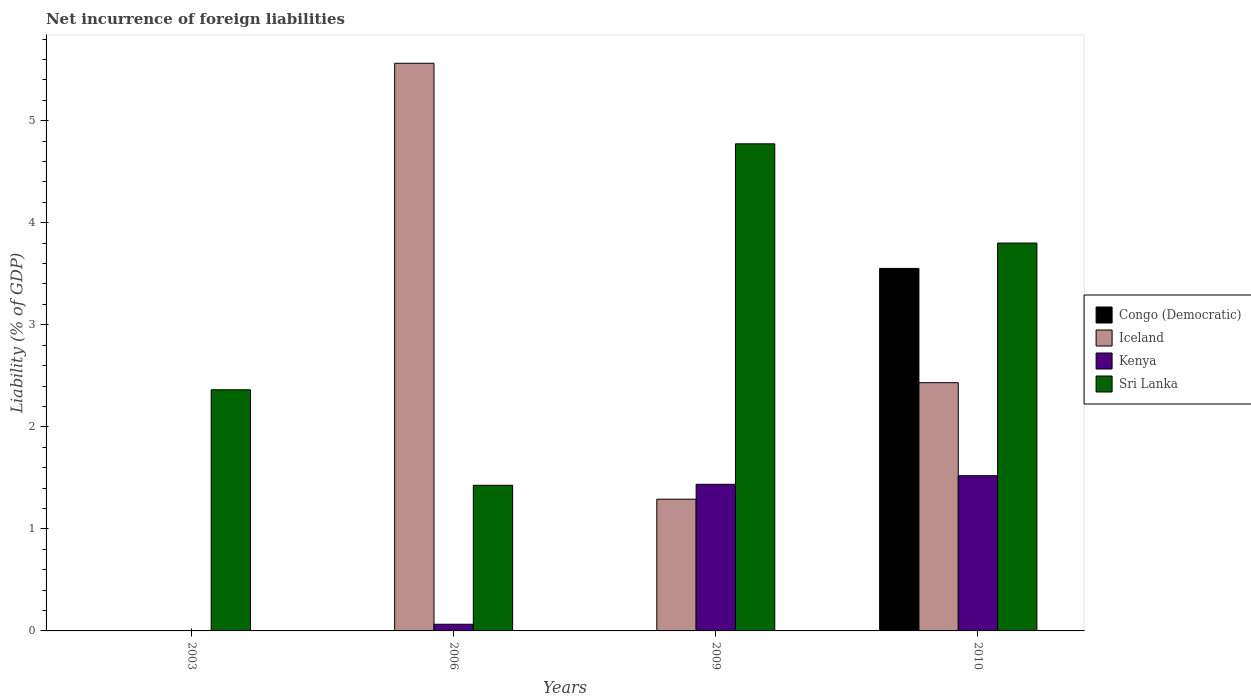How many different coloured bars are there?
Ensure brevity in your answer.  4. Are the number of bars per tick equal to the number of legend labels?
Your answer should be compact. No. Are the number of bars on each tick of the X-axis equal?
Provide a short and direct response. No. How many bars are there on the 3rd tick from the left?
Give a very brief answer. 3. How many bars are there on the 2nd tick from the right?
Give a very brief answer. 3. What is the label of the 2nd group of bars from the left?
Offer a very short reply. 2006. In how many cases, is the number of bars for a given year not equal to the number of legend labels?
Ensure brevity in your answer.  3. What is the net incurrence of foreign liabilities in Kenya in 2010?
Give a very brief answer. 1.52. Across all years, what is the maximum net incurrence of foreign liabilities in Congo (Democratic)?
Your answer should be very brief. 3.55. Across all years, what is the minimum net incurrence of foreign liabilities in Sri Lanka?
Give a very brief answer. 1.43. In which year was the net incurrence of foreign liabilities in Kenya maximum?
Ensure brevity in your answer.  2010. What is the total net incurrence of foreign liabilities in Kenya in the graph?
Provide a succinct answer. 3.02. What is the difference between the net incurrence of foreign liabilities in Kenya in 2009 and that in 2010?
Give a very brief answer. -0.08. What is the difference between the net incurrence of foreign liabilities in Iceland in 2003 and the net incurrence of foreign liabilities in Congo (Democratic) in 2009?
Offer a terse response. 0. What is the average net incurrence of foreign liabilities in Sri Lanka per year?
Offer a very short reply. 3.09. In the year 2010, what is the difference between the net incurrence of foreign liabilities in Iceland and net incurrence of foreign liabilities in Sri Lanka?
Provide a short and direct response. -1.37. In how many years, is the net incurrence of foreign liabilities in Sri Lanka greater than 1 %?
Your response must be concise. 4. What is the ratio of the net incurrence of foreign liabilities in Sri Lanka in 2006 to that in 2009?
Provide a succinct answer. 0.3. What is the difference between the highest and the second highest net incurrence of foreign liabilities in Iceland?
Make the answer very short. 3.13. What is the difference between the highest and the lowest net incurrence of foreign liabilities in Iceland?
Offer a very short reply. 5.56. In how many years, is the net incurrence of foreign liabilities in Iceland greater than the average net incurrence of foreign liabilities in Iceland taken over all years?
Provide a short and direct response. 2. How many years are there in the graph?
Provide a short and direct response. 4. What is the difference between two consecutive major ticks on the Y-axis?
Offer a terse response. 1. Are the values on the major ticks of Y-axis written in scientific E-notation?
Offer a very short reply. No. Does the graph contain any zero values?
Offer a terse response. Yes. Does the graph contain grids?
Provide a short and direct response. No. Where does the legend appear in the graph?
Your answer should be very brief. Center right. How many legend labels are there?
Ensure brevity in your answer.  4. How are the legend labels stacked?
Give a very brief answer. Vertical. What is the title of the graph?
Your response must be concise. Net incurrence of foreign liabilities. What is the label or title of the X-axis?
Ensure brevity in your answer.  Years. What is the label or title of the Y-axis?
Your answer should be compact. Liability (% of GDP). What is the Liability (% of GDP) in Congo (Democratic) in 2003?
Give a very brief answer. 0. What is the Liability (% of GDP) of Iceland in 2003?
Give a very brief answer. 0. What is the Liability (% of GDP) of Kenya in 2003?
Keep it short and to the point. 0. What is the Liability (% of GDP) of Sri Lanka in 2003?
Give a very brief answer. 2.36. What is the Liability (% of GDP) of Congo (Democratic) in 2006?
Your answer should be very brief. 0. What is the Liability (% of GDP) in Iceland in 2006?
Make the answer very short. 5.56. What is the Liability (% of GDP) of Kenya in 2006?
Provide a succinct answer. 0.07. What is the Liability (% of GDP) in Sri Lanka in 2006?
Give a very brief answer. 1.43. What is the Liability (% of GDP) of Iceland in 2009?
Your answer should be very brief. 1.29. What is the Liability (% of GDP) of Kenya in 2009?
Your answer should be compact. 1.44. What is the Liability (% of GDP) of Sri Lanka in 2009?
Ensure brevity in your answer.  4.77. What is the Liability (% of GDP) of Congo (Democratic) in 2010?
Offer a very short reply. 3.55. What is the Liability (% of GDP) in Iceland in 2010?
Offer a terse response. 2.43. What is the Liability (% of GDP) of Kenya in 2010?
Keep it short and to the point. 1.52. What is the Liability (% of GDP) of Sri Lanka in 2010?
Your answer should be very brief. 3.8. Across all years, what is the maximum Liability (% of GDP) in Congo (Democratic)?
Your response must be concise. 3.55. Across all years, what is the maximum Liability (% of GDP) of Iceland?
Give a very brief answer. 5.56. Across all years, what is the maximum Liability (% of GDP) of Kenya?
Give a very brief answer. 1.52. Across all years, what is the maximum Liability (% of GDP) in Sri Lanka?
Your answer should be very brief. 4.77. Across all years, what is the minimum Liability (% of GDP) of Kenya?
Keep it short and to the point. 0. Across all years, what is the minimum Liability (% of GDP) in Sri Lanka?
Your answer should be very brief. 1.43. What is the total Liability (% of GDP) of Congo (Democratic) in the graph?
Keep it short and to the point. 3.55. What is the total Liability (% of GDP) of Iceland in the graph?
Offer a terse response. 9.29. What is the total Liability (% of GDP) of Kenya in the graph?
Give a very brief answer. 3.02. What is the total Liability (% of GDP) of Sri Lanka in the graph?
Your answer should be very brief. 12.36. What is the difference between the Liability (% of GDP) of Sri Lanka in 2003 and that in 2006?
Your answer should be compact. 0.94. What is the difference between the Liability (% of GDP) in Sri Lanka in 2003 and that in 2009?
Ensure brevity in your answer.  -2.41. What is the difference between the Liability (% of GDP) of Sri Lanka in 2003 and that in 2010?
Offer a very short reply. -1.44. What is the difference between the Liability (% of GDP) in Iceland in 2006 and that in 2009?
Provide a short and direct response. 4.27. What is the difference between the Liability (% of GDP) of Kenya in 2006 and that in 2009?
Provide a succinct answer. -1.37. What is the difference between the Liability (% of GDP) in Sri Lanka in 2006 and that in 2009?
Keep it short and to the point. -3.35. What is the difference between the Liability (% of GDP) in Iceland in 2006 and that in 2010?
Offer a terse response. 3.13. What is the difference between the Liability (% of GDP) of Kenya in 2006 and that in 2010?
Provide a short and direct response. -1.46. What is the difference between the Liability (% of GDP) of Sri Lanka in 2006 and that in 2010?
Offer a very short reply. -2.37. What is the difference between the Liability (% of GDP) of Iceland in 2009 and that in 2010?
Keep it short and to the point. -1.14. What is the difference between the Liability (% of GDP) of Kenya in 2009 and that in 2010?
Offer a terse response. -0.08. What is the difference between the Liability (% of GDP) of Sri Lanka in 2009 and that in 2010?
Make the answer very short. 0.97. What is the difference between the Liability (% of GDP) of Iceland in 2006 and the Liability (% of GDP) of Kenya in 2009?
Make the answer very short. 4.13. What is the difference between the Liability (% of GDP) in Iceland in 2006 and the Liability (% of GDP) in Sri Lanka in 2009?
Ensure brevity in your answer.  0.79. What is the difference between the Liability (% of GDP) of Kenya in 2006 and the Liability (% of GDP) of Sri Lanka in 2009?
Offer a terse response. -4.71. What is the difference between the Liability (% of GDP) in Iceland in 2006 and the Liability (% of GDP) in Kenya in 2010?
Make the answer very short. 4.04. What is the difference between the Liability (% of GDP) in Iceland in 2006 and the Liability (% of GDP) in Sri Lanka in 2010?
Your answer should be very brief. 1.76. What is the difference between the Liability (% of GDP) of Kenya in 2006 and the Liability (% of GDP) of Sri Lanka in 2010?
Ensure brevity in your answer.  -3.74. What is the difference between the Liability (% of GDP) of Iceland in 2009 and the Liability (% of GDP) of Kenya in 2010?
Provide a succinct answer. -0.23. What is the difference between the Liability (% of GDP) of Iceland in 2009 and the Liability (% of GDP) of Sri Lanka in 2010?
Make the answer very short. -2.51. What is the difference between the Liability (% of GDP) of Kenya in 2009 and the Liability (% of GDP) of Sri Lanka in 2010?
Make the answer very short. -2.36. What is the average Liability (% of GDP) in Congo (Democratic) per year?
Provide a succinct answer. 0.89. What is the average Liability (% of GDP) in Iceland per year?
Keep it short and to the point. 2.32. What is the average Liability (% of GDP) in Kenya per year?
Your answer should be very brief. 0.76. What is the average Liability (% of GDP) of Sri Lanka per year?
Provide a short and direct response. 3.09. In the year 2006, what is the difference between the Liability (% of GDP) in Iceland and Liability (% of GDP) in Kenya?
Offer a very short reply. 5.5. In the year 2006, what is the difference between the Liability (% of GDP) of Iceland and Liability (% of GDP) of Sri Lanka?
Make the answer very short. 4.14. In the year 2006, what is the difference between the Liability (% of GDP) of Kenya and Liability (% of GDP) of Sri Lanka?
Keep it short and to the point. -1.36. In the year 2009, what is the difference between the Liability (% of GDP) in Iceland and Liability (% of GDP) in Kenya?
Offer a very short reply. -0.15. In the year 2009, what is the difference between the Liability (% of GDP) in Iceland and Liability (% of GDP) in Sri Lanka?
Offer a terse response. -3.48. In the year 2009, what is the difference between the Liability (% of GDP) in Kenya and Liability (% of GDP) in Sri Lanka?
Keep it short and to the point. -3.34. In the year 2010, what is the difference between the Liability (% of GDP) in Congo (Democratic) and Liability (% of GDP) in Iceland?
Offer a terse response. 1.12. In the year 2010, what is the difference between the Liability (% of GDP) of Congo (Democratic) and Liability (% of GDP) of Kenya?
Ensure brevity in your answer.  2.03. In the year 2010, what is the difference between the Liability (% of GDP) in Congo (Democratic) and Liability (% of GDP) in Sri Lanka?
Give a very brief answer. -0.25. In the year 2010, what is the difference between the Liability (% of GDP) in Iceland and Liability (% of GDP) in Kenya?
Your response must be concise. 0.91. In the year 2010, what is the difference between the Liability (% of GDP) of Iceland and Liability (% of GDP) of Sri Lanka?
Offer a very short reply. -1.37. In the year 2010, what is the difference between the Liability (% of GDP) of Kenya and Liability (% of GDP) of Sri Lanka?
Offer a very short reply. -2.28. What is the ratio of the Liability (% of GDP) in Sri Lanka in 2003 to that in 2006?
Ensure brevity in your answer.  1.66. What is the ratio of the Liability (% of GDP) of Sri Lanka in 2003 to that in 2009?
Keep it short and to the point. 0.49. What is the ratio of the Liability (% of GDP) in Sri Lanka in 2003 to that in 2010?
Make the answer very short. 0.62. What is the ratio of the Liability (% of GDP) of Iceland in 2006 to that in 2009?
Make the answer very short. 4.31. What is the ratio of the Liability (% of GDP) of Kenya in 2006 to that in 2009?
Give a very brief answer. 0.05. What is the ratio of the Liability (% of GDP) in Sri Lanka in 2006 to that in 2009?
Your answer should be compact. 0.3. What is the ratio of the Liability (% of GDP) of Iceland in 2006 to that in 2010?
Offer a terse response. 2.29. What is the ratio of the Liability (% of GDP) in Kenya in 2006 to that in 2010?
Provide a succinct answer. 0.04. What is the ratio of the Liability (% of GDP) of Sri Lanka in 2006 to that in 2010?
Ensure brevity in your answer.  0.38. What is the ratio of the Liability (% of GDP) in Iceland in 2009 to that in 2010?
Give a very brief answer. 0.53. What is the ratio of the Liability (% of GDP) in Kenya in 2009 to that in 2010?
Make the answer very short. 0.94. What is the ratio of the Liability (% of GDP) of Sri Lanka in 2009 to that in 2010?
Your response must be concise. 1.26. What is the difference between the highest and the second highest Liability (% of GDP) in Iceland?
Your answer should be very brief. 3.13. What is the difference between the highest and the second highest Liability (% of GDP) of Kenya?
Make the answer very short. 0.08. What is the difference between the highest and the second highest Liability (% of GDP) of Sri Lanka?
Offer a terse response. 0.97. What is the difference between the highest and the lowest Liability (% of GDP) of Congo (Democratic)?
Offer a terse response. 3.55. What is the difference between the highest and the lowest Liability (% of GDP) of Iceland?
Your answer should be very brief. 5.56. What is the difference between the highest and the lowest Liability (% of GDP) of Kenya?
Provide a succinct answer. 1.52. What is the difference between the highest and the lowest Liability (% of GDP) in Sri Lanka?
Your answer should be very brief. 3.35. 